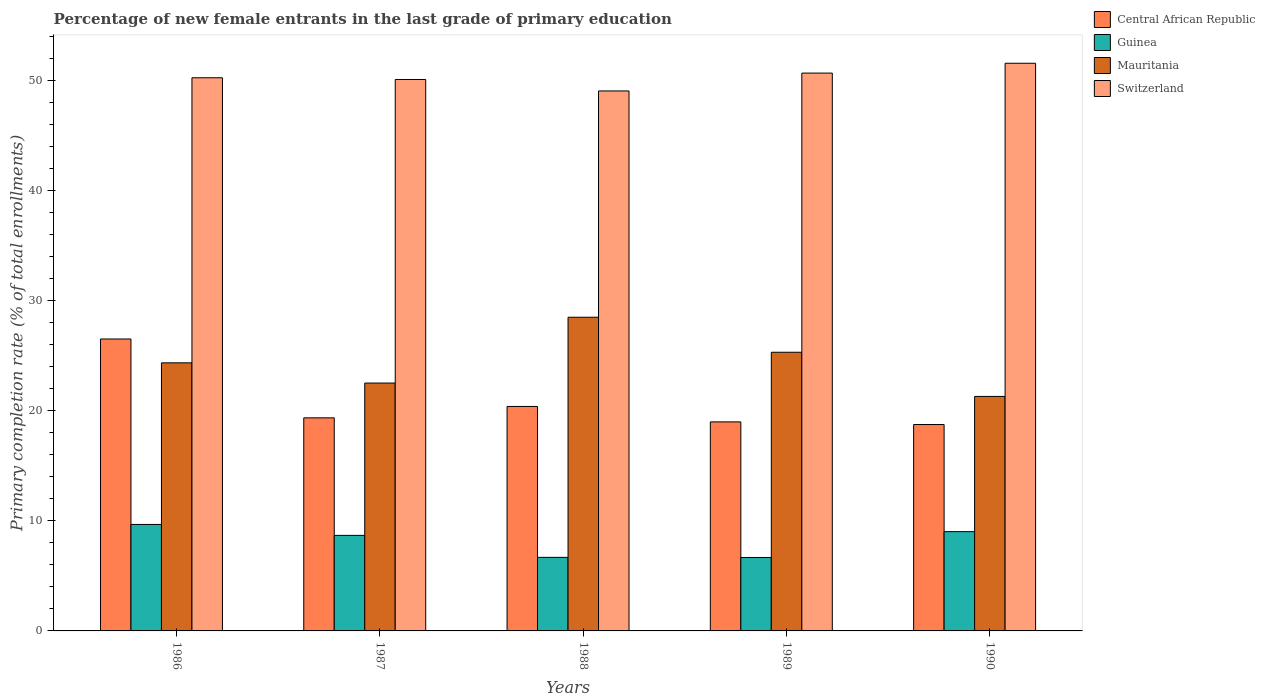Are the number of bars per tick equal to the number of legend labels?
Provide a succinct answer. Yes. How many bars are there on the 5th tick from the left?
Make the answer very short. 4. How many bars are there on the 3rd tick from the right?
Ensure brevity in your answer.  4. What is the percentage of new female entrants in Guinea in 1986?
Give a very brief answer. 9.67. Across all years, what is the maximum percentage of new female entrants in Guinea?
Your answer should be compact. 9.67. Across all years, what is the minimum percentage of new female entrants in Mauritania?
Provide a short and direct response. 21.31. In which year was the percentage of new female entrants in Guinea maximum?
Make the answer very short. 1986. In which year was the percentage of new female entrants in Mauritania minimum?
Keep it short and to the point. 1990. What is the total percentage of new female entrants in Guinea in the graph?
Give a very brief answer. 40.73. What is the difference between the percentage of new female entrants in Switzerland in 1986 and that in 1988?
Provide a short and direct response. 1.2. What is the difference between the percentage of new female entrants in Switzerland in 1987 and the percentage of new female entrants in Central African Republic in 1989?
Your response must be concise. 31.11. What is the average percentage of new female entrants in Mauritania per year?
Give a very brief answer. 24.4. In the year 1988, what is the difference between the percentage of new female entrants in Central African Republic and percentage of new female entrants in Guinea?
Your answer should be very brief. 13.71. What is the ratio of the percentage of new female entrants in Central African Republic in 1987 to that in 1990?
Your answer should be compact. 1.03. Is the percentage of new female entrants in Switzerland in 1987 less than that in 1989?
Provide a short and direct response. Yes. Is the difference between the percentage of new female entrants in Central African Republic in 1986 and 1989 greater than the difference between the percentage of new female entrants in Guinea in 1986 and 1989?
Offer a terse response. Yes. What is the difference between the highest and the second highest percentage of new female entrants in Switzerland?
Offer a terse response. 0.89. What is the difference between the highest and the lowest percentage of new female entrants in Mauritania?
Ensure brevity in your answer.  7.2. Is the sum of the percentage of new female entrants in Mauritania in 1986 and 1988 greater than the maximum percentage of new female entrants in Switzerland across all years?
Offer a terse response. Yes. What does the 3rd bar from the left in 1988 represents?
Ensure brevity in your answer.  Mauritania. What does the 3rd bar from the right in 1987 represents?
Offer a terse response. Guinea. How many bars are there?
Your response must be concise. 20. Are all the bars in the graph horizontal?
Provide a succinct answer. No. What is the difference between two consecutive major ticks on the Y-axis?
Provide a short and direct response. 10. Are the values on the major ticks of Y-axis written in scientific E-notation?
Provide a short and direct response. No. Does the graph contain any zero values?
Your answer should be compact. No. Does the graph contain grids?
Offer a terse response. No. How many legend labels are there?
Ensure brevity in your answer.  4. What is the title of the graph?
Provide a short and direct response. Percentage of new female entrants in the last grade of primary education. Does "Myanmar" appear as one of the legend labels in the graph?
Ensure brevity in your answer.  No. What is the label or title of the Y-axis?
Offer a very short reply. Primary completion rate (% of total enrollments). What is the Primary completion rate (% of total enrollments) of Central African Republic in 1986?
Give a very brief answer. 26.53. What is the Primary completion rate (% of total enrollments) of Guinea in 1986?
Make the answer very short. 9.67. What is the Primary completion rate (% of total enrollments) in Mauritania in 1986?
Keep it short and to the point. 24.36. What is the Primary completion rate (% of total enrollments) in Switzerland in 1986?
Give a very brief answer. 50.26. What is the Primary completion rate (% of total enrollments) in Central African Republic in 1987?
Provide a short and direct response. 19.36. What is the Primary completion rate (% of total enrollments) of Guinea in 1987?
Offer a very short reply. 8.68. What is the Primary completion rate (% of total enrollments) of Mauritania in 1987?
Give a very brief answer. 22.52. What is the Primary completion rate (% of total enrollments) in Switzerland in 1987?
Your answer should be compact. 50.11. What is the Primary completion rate (% of total enrollments) in Central African Republic in 1988?
Offer a terse response. 20.4. What is the Primary completion rate (% of total enrollments) in Guinea in 1988?
Offer a very short reply. 6.68. What is the Primary completion rate (% of total enrollments) in Mauritania in 1988?
Ensure brevity in your answer.  28.5. What is the Primary completion rate (% of total enrollments) in Switzerland in 1988?
Your response must be concise. 49.06. What is the Primary completion rate (% of total enrollments) in Central African Republic in 1989?
Provide a short and direct response. 18.99. What is the Primary completion rate (% of total enrollments) of Guinea in 1989?
Give a very brief answer. 6.67. What is the Primary completion rate (% of total enrollments) of Mauritania in 1989?
Your answer should be compact. 25.32. What is the Primary completion rate (% of total enrollments) in Switzerland in 1989?
Your answer should be very brief. 50.69. What is the Primary completion rate (% of total enrollments) in Central African Republic in 1990?
Give a very brief answer. 18.75. What is the Primary completion rate (% of total enrollments) in Guinea in 1990?
Your answer should be compact. 9.02. What is the Primary completion rate (% of total enrollments) of Mauritania in 1990?
Ensure brevity in your answer.  21.31. What is the Primary completion rate (% of total enrollments) of Switzerland in 1990?
Provide a succinct answer. 51.58. Across all years, what is the maximum Primary completion rate (% of total enrollments) of Central African Republic?
Your answer should be compact. 26.53. Across all years, what is the maximum Primary completion rate (% of total enrollments) of Guinea?
Give a very brief answer. 9.67. Across all years, what is the maximum Primary completion rate (% of total enrollments) in Mauritania?
Provide a succinct answer. 28.5. Across all years, what is the maximum Primary completion rate (% of total enrollments) of Switzerland?
Your response must be concise. 51.58. Across all years, what is the minimum Primary completion rate (% of total enrollments) of Central African Republic?
Offer a terse response. 18.75. Across all years, what is the minimum Primary completion rate (% of total enrollments) of Guinea?
Your answer should be compact. 6.67. Across all years, what is the minimum Primary completion rate (% of total enrollments) in Mauritania?
Provide a short and direct response. 21.31. Across all years, what is the minimum Primary completion rate (% of total enrollments) of Switzerland?
Ensure brevity in your answer.  49.06. What is the total Primary completion rate (% of total enrollments) in Central African Republic in the graph?
Your response must be concise. 104.03. What is the total Primary completion rate (% of total enrollments) in Guinea in the graph?
Give a very brief answer. 40.73. What is the total Primary completion rate (% of total enrollments) in Mauritania in the graph?
Your answer should be very brief. 122.01. What is the total Primary completion rate (% of total enrollments) of Switzerland in the graph?
Provide a short and direct response. 251.7. What is the difference between the Primary completion rate (% of total enrollments) of Central African Republic in 1986 and that in 1987?
Provide a short and direct response. 7.16. What is the difference between the Primary completion rate (% of total enrollments) in Guinea in 1986 and that in 1987?
Offer a very short reply. 0.99. What is the difference between the Primary completion rate (% of total enrollments) in Mauritania in 1986 and that in 1987?
Make the answer very short. 1.84. What is the difference between the Primary completion rate (% of total enrollments) of Switzerland in 1986 and that in 1987?
Keep it short and to the point. 0.16. What is the difference between the Primary completion rate (% of total enrollments) of Central African Republic in 1986 and that in 1988?
Offer a terse response. 6.13. What is the difference between the Primary completion rate (% of total enrollments) in Guinea in 1986 and that in 1988?
Offer a terse response. 2.99. What is the difference between the Primary completion rate (% of total enrollments) of Mauritania in 1986 and that in 1988?
Provide a succinct answer. -4.14. What is the difference between the Primary completion rate (% of total enrollments) of Switzerland in 1986 and that in 1988?
Your answer should be very brief. 1.2. What is the difference between the Primary completion rate (% of total enrollments) of Central African Republic in 1986 and that in 1989?
Your answer should be very brief. 7.53. What is the difference between the Primary completion rate (% of total enrollments) in Guinea in 1986 and that in 1989?
Provide a succinct answer. 3. What is the difference between the Primary completion rate (% of total enrollments) of Mauritania in 1986 and that in 1989?
Ensure brevity in your answer.  -0.96. What is the difference between the Primary completion rate (% of total enrollments) in Switzerland in 1986 and that in 1989?
Provide a succinct answer. -0.43. What is the difference between the Primary completion rate (% of total enrollments) of Central African Republic in 1986 and that in 1990?
Give a very brief answer. 7.77. What is the difference between the Primary completion rate (% of total enrollments) of Guinea in 1986 and that in 1990?
Give a very brief answer. 0.65. What is the difference between the Primary completion rate (% of total enrollments) of Mauritania in 1986 and that in 1990?
Your answer should be compact. 3.05. What is the difference between the Primary completion rate (% of total enrollments) of Switzerland in 1986 and that in 1990?
Your answer should be very brief. -1.32. What is the difference between the Primary completion rate (% of total enrollments) in Central African Republic in 1987 and that in 1988?
Make the answer very short. -1.03. What is the difference between the Primary completion rate (% of total enrollments) in Guinea in 1987 and that in 1988?
Offer a very short reply. 2. What is the difference between the Primary completion rate (% of total enrollments) of Mauritania in 1987 and that in 1988?
Provide a short and direct response. -5.98. What is the difference between the Primary completion rate (% of total enrollments) of Switzerland in 1987 and that in 1988?
Give a very brief answer. 1.04. What is the difference between the Primary completion rate (% of total enrollments) in Central African Republic in 1987 and that in 1989?
Your answer should be very brief. 0.37. What is the difference between the Primary completion rate (% of total enrollments) in Guinea in 1987 and that in 1989?
Provide a short and direct response. 2.01. What is the difference between the Primary completion rate (% of total enrollments) in Mauritania in 1987 and that in 1989?
Give a very brief answer. -2.8. What is the difference between the Primary completion rate (% of total enrollments) of Switzerland in 1987 and that in 1989?
Offer a terse response. -0.58. What is the difference between the Primary completion rate (% of total enrollments) in Central African Republic in 1987 and that in 1990?
Give a very brief answer. 0.61. What is the difference between the Primary completion rate (% of total enrollments) of Guinea in 1987 and that in 1990?
Your answer should be very brief. -0.34. What is the difference between the Primary completion rate (% of total enrollments) in Mauritania in 1987 and that in 1990?
Keep it short and to the point. 1.22. What is the difference between the Primary completion rate (% of total enrollments) of Switzerland in 1987 and that in 1990?
Make the answer very short. -1.47. What is the difference between the Primary completion rate (% of total enrollments) in Central African Republic in 1988 and that in 1989?
Ensure brevity in your answer.  1.4. What is the difference between the Primary completion rate (% of total enrollments) in Guinea in 1988 and that in 1989?
Make the answer very short. 0.01. What is the difference between the Primary completion rate (% of total enrollments) in Mauritania in 1988 and that in 1989?
Give a very brief answer. 3.18. What is the difference between the Primary completion rate (% of total enrollments) of Switzerland in 1988 and that in 1989?
Your answer should be very brief. -1.62. What is the difference between the Primary completion rate (% of total enrollments) in Central African Republic in 1988 and that in 1990?
Ensure brevity in your answer.  1.64. What is the difference between the Primary completion rate (% of total enrollments) in Guinea in 1988 and that in 1990?
Your response must be concise. -2.34. What is the difference between the Primary completion rate (% of total enrollments) of Mauritania in 1988 and that in 1990?
Your answer should be compact. 7.2. What is the difference between the Primary completion rate (% of total enrollments) in Switzerland in 1988 and that in 1990?
Your answer should be compact. -2.52. What is the difference between the Primary completion rate (% of total enrollments) of Central African Republic in 1989 and that in 1990?
Offer a terse response. 0.24. What is the difference between the Primary completion rate (% of total enrollments) of Guinea in 1989 and that in 1990?
Keep it short and to the point. -2.35. What is the difference between the Primary completion rate (% of total enrollments) of Mauritania in 1989 and that in 1990?
Your answer should be very brief. 4.01. What is the difference between the Primary completion rate (% of total enrollments) in Switzerland in 1989 and that in 1990?
Your response must be concise. -0.89. What is the difference between the Primary completion rate (% of total enrollments) of Central African Republic in 1986 and the Primary completion rate (% of total enrollments) of Guinea in 1987?
Offer a terse response. 17.84. What is the difference between the Primary completion rate (% of total enrollments) of Central African Republic in 1986 and the Primary completion rate (% of total enrollments) of Mauritania in 1987?
Offer a very short reply. 4. What is the difference between the Primary completion rate (% of total enrollments) in Central African Republic in 1986 and the Primary completion rate (% of total enrollments) in Switzerland in 1987?
Offer a terse response. -23.58. What is the difference between the Primary completion rate (% of total enrollments) in Guinea in 1986 and the Primary completion rate (% of total enrollments) in Mauritania in 1987?
Your answer should be compact. -12.85. What is the difference between the Primary completion rate (% of total enrollments) of Guinea in 1986 and the Primary completion rate (% of total enrollments) of Switzerland in 1987?
Your answer should be very brief. -40.43. What is the difference between the Primary completion rate (% of total enrollments) of Mauritania in 1986 and the Primary completion rate (% of total enrollments) of Switzerland in 1987?
Make the answer very short. -25.75. What is the difference between the Primary completion rate (% of total enrollments) in Central African Republic in 1986 and the Primary completion rate (% of total enrollments) in Guinea in 1988?
Make the answer very short. 19.84. What is the difference between the Primary completion rate (% of total enrollments) of Central African Republic in 1986 and the Primary completion rate (% of total enrollments) of Mauritania in 1988?
Provide a short and direct response. -1.98. What is the difference between the Primary completion rate (% of total enrollments) in Central African Republic in 1986 and the Primary completion rate (% of total enrollments) in Switzerland in 1988?
Give a very brief answer. -22.54. What is the difference between the Primary completion rate (% of total enrollments) in Guinea in 1986 and the Primary completion rate (% of total enrollments) in Mauritania in 1988?
Your answer should be compact. -18.83. What is the difference between the Primary completion rate (% of total enrollments) of Guinea in 1986 and the Primary completion rate (% of total enrollments) of Switzerland in 1988?
Ensure brevity in your answer.  -39.39. What is the difference between the Primary completion rate (% of total enrollments) in Mauritania in 1986 and the Primary completion rate (% of total enrollments) in Switzerland in 1988?
Ensure brevity in your answer.  -24.71. What is the difference between the Primary completion rate (% of total enrollments) in Central African Republic in 1986 and the Primary completion rate (% of total enrollments) in Guinea in 1989?
Keep it short and to the point. 19.85. What is the difference between the Primary completion rate (% of total enrollments) in Central African Republic in 1986 and the Primary completion rate (% of total enrollments) in Mauritania in 1989?
Your answer should be very brief. 1.21. What is the difference between the Primary completion rate (% of total enrollments) in Central African Republic in 1986 and the Primary completion rate (% of total enrollments) in Switzerland in 1989?
Offer a terse response. -24.16. What is the difference between the Primary completion rate (% of total enrollments) of Guinea in 1986 and the Primary completion rate (% of total enrollments) of Mauritania in 1989?
Offer a very short reply. -15.65. What is the difference between the Primary completion rate (% of total enrollments) of Guinea in 1986 and the Primary completion rate (% of total enrollments) of Switzerland in 1989?
Make the answer very short. -41.01. What is the difference between the Primary completion rate (% of total enrollments) in Mauritania in 1986 and the Primary completion rate (% of total enrollments) in Switzerland in 1989?
Make the answer very short. -26.33. What is the difference between the Primary completion rate (% of total enrollments) of Central African Republic in 1986 and the Primary completion rate (% of total enrollments) of Guinea in 1990?
Give a very brief answer. 17.5. What is the difference between the Primary completion rate (% of total enrollments) of Central African Republic in 1986 and the Primary completion rate (% of total enrollments) of Mauritania in 1990?
Your answer should be very brief. 5.22. What is the difference between the Primary completion rate (% of total enrollments) of Central African Republic in 1986 and the Primary completion rate (% of total enrollments) of Switzerland in 1990?
Give a very brief answer. -25.05. What is the difference between the Primary completion rate (% of total enrollments) in Guinea in 1986 and the Primary completion rate (% of total enrollments) in Mauritania in 1990?
Ensure brevity in your answer.  -11.63. What is the difference between the Primary completion rate (% of total enrollments) of Guinea in 1986 and the Primary completion rate (% of total enrollments) of Switzerland in 1990?
Offer a very short reply. -41.91. What is the difference between the Primary completion rate (% of total enrollments) in Mauritania in 1986 and the Primary completion rate (% of total enrollments) in Switzerland in 1990?
Give a very brief answer. -27.22. What is the difference between the Primary completion rate (% of total enrollments) in Central African Republic in 1987 and the Primary completion rate (% of total enrollments) in Guinea in 1988?
Give a very brief answer. 12.68. What is the difference between the Primary completion rate (% of total enrollments) in Central African Republic in 1987 and the Primary completion rate (% of total enrollments) in Mauritania in 1988?
Provide a short and direct response. -9.14. What is the difference between the Primary completion rate (% of total enrollments) of Central African Republic in 1987 and the Primary completion rate (% of total enrollments) of Switzerland in 1988?
Provide a succinct answer. -29.7. What is the difference between the Primary completion rate (% of total enrollments) of Guinea in 1987 and the Primary completion rate (% of total enrollments) of Mauritania in 1988?
Your answer should be very brief. -19.82. What is the difference between the Primary completion rate (% of total enrollments) of Guinea in 1987 and the Primary completion rate (% of total enrollments) of Switzerland in 1988?
Ensure brevity in your answer.  -40.38. What is the difference between the Primary completion rate (% of total enrollments) of Mauritania in 1987 and the Primary completion rate (% of total enrollments) of Switzerland in 1988?
Provide a succinct answer. -26.54. What is the difference between the Primary completion rate (% of total enrollments) in Central African Republic in 1987 and the Primary completion rate (% of total enrollments) in Guinea in 1989?
Ensure brevity in your answer.  12.69. What is the difference between the Primary completion rate (% of total enrollments) of Central African Republic in 1987 and the Primary completion rate (% of total enrollments) of Mauritania in 1989?
Offer a terse response. -5.96. What is the difference between the Primary completion rate (% of total enrollments) of Central African Republic in 1987 and the Primary completion rate (% of total enrollments) of Switzerland in 1989?
Make the answer very short. -31.33. What is the difference between the Primary completion rate (% of total enrollments) of Guinea in 1987 and the Primary completion rate (% of total enrollments) of Mauritania in 1989?
Your answer should be very brief. -16.64. What is the difference between the Primary completion rate (% of total enrollments) in Guinea in 1987 and the Primary completion rate (% of total enrollments) in Switzerland in 1989?
Make the answer very short. -42.01. What is the difference between the Primary completion rate (% of total enrollments) of Mauritania in 1987 and the Primary completion rate (% of total enrollments) of Switzerland in 1989?
Offer a very short reply. -28.17. What is the difference between the Primary completion rate (% of total enrollments) of Central African Republic in 1987 and the Primary completion rate (% of total enrollments) of Guinea in 1990?
Make the answer very short. 10.34. What is the difference between the Primary completion rate (% of total enrollments) in Central African Republic in 1987 and the Primary completion rate (% of total enrollments) in Mauritania in 1990?
Give a very brief answer. -1.95. What is the difference between the Primary completion rate (% of total enrollments) of Central African Republic in 1987 and the Primary completion rate (% of total enrollments) of Switzerland in 1990?
Your answer should be compact. -32.22. What is the difference between the Primary completion rate (% of total enrollments) in Guinea in 1987 and the Primary completion rate (% of total enrollments) in Mauritania in 1990?
Make the answer very short. -12.62. What is the difference between the Primary completion rate (% of total enrollments) of Guinea in 1987 and the Primary completion rate (% of total enrollments) of Switzerland in 1990?
Provide a short and direct response. -42.9. What is the difference between the Primary completion rate (% of total enrollments) of Mauritania in 1987 and the Primary completion rate (% of total enrollments) of Switzerland in 1990?
Ensure brevity in your answer.  -29.06. What is the difference between the Primary completion rate (% of total enrollments) of Central African Republic in 1988 and the Primary completion rate (% of total enrollments) of Guinea in 1989?
Offer a terse response. 13.72. What is the difference between the Primary completion rate (% of total enrollments) of Central African Republic in 1988 and the Primary completion rate (% of total enrollments) of Mauritania in 1989?
Provide a short and direct response. -4.92. What is the difference between the Primary completion rate (% of total enrollments) in Central African Republic in 1988 and the Primary completion rate (% of total enrollments) in Switzerland in 1989?
Your answer should be very brief. -30.29. What is the difference between the Primary completion rate (% of total enrollments) of Guinea in 1988 and the Primary completion rate (% of total enrollments) of Mauritania in 1989?
Give a very brief answer. -18.64. What is the difference between the Primary completion rate (% of total enrollments) of Guinea in 1988 and the Primary completion rate (% of total enrollments) of Switzerland in 1989?
Your response must be concise. -44. What is the difference between the Primary completion rate (% of total enrollments) of Mauritania in 1988 and the Primary completion rate (% of total enrollments) of Switzerland in 1989?
Provide a succinct answer. -22.19. What is the difference between the Primary completion rate (% of total enrollments) of Central African Republic in 1988 and the Primary completion rate (% of total enrollments) of Guinea in 1990?
Your answer should be very brief. 11.37. What is the difference between the Primary completion rate (% of total enrollments) in Central African Republic in 1988 and the Primary completion rate (% of total enrollments) in Mauritania in 1990?
Make the answer very short. -0.91. What is the difference between the Primary completion rate (% of total enrollments) in Central African Republic in 1988 and the Primary completion rate (% of total enrollments) in Switzerland in 1990?
Offer a terse response. -31.18. What is the difference between the Primary completion rate (% of total enrollments) in Guinea in 1988 and the Primary completion rate (% of total enrollments) in Mauritania in 1990?
Offer a terse response. -14.62. What is the difference between the Primary completion rate (% of total enrollments) in Guinea in 1988 and the Primary completion rate (% of total enrollments) in Switzerland in 1990?
Keep it short and to the point. -44.9. What is the difference between the Primary completion rate (% of total enrollments) in Mauritania in 1988 and the Primary completion rate (% of total enrollments) in Switzerland in 1990?
Offer a very short reply. -23.08. What is the difference between the Primary completion rate (% of total enrollments) in Central African Republic in 1989 and the Primary completion rate (% of total enrollments) in Guinea in 1990?
Keep it short and to the point. 9.97. What is the difference between the Primary completion rate (% of total enrollments) in Central African Republic in 1989 and the Primary completion rate (% of total enrollments) in Mauritania in 1990?
Offer a very short reply. -2.31. What is the difference between the Primary completion rate (% of total enrollments) in Central African Republic in 1989 and the Primary completion rate (% of total enrollments) in Switzerland in 1990?
Offer a terse response. -32.59. What is the difference between the Primary completion rate (% of total enrollments) in Guinea in 1989 and the Primary completion rate (% of total enrollments) in Mauritania in 1990?
Give a very brief answer. -14.63. What is the difference between the Primary completion rate (% of total enrollments) of Guinea in 1989 and the Primary completion rate (% of total enrollments) of Switzerland in 1990?
Offer a terse response. -44.91. What is the difference between the Primary completion rate (% of total enrollments) in Mauritania in 1989 and the Primary completion rate (% of total enrollments) in Switzerland in 1990?
Offer a very short reply. -26.26. What is the average Primary completion rate (% of total enrollments) of Central African Republic per year?
Keep it short and to the point. 20.81. What is the average Primary completion rate (% of total enrollments) in Guinea per year?
Provide a short and direct response. 8.15. What is the average Primary completion rate (% of total enrollments) of Mauritania per year?
Your answer should be compact. 24.4. What is the average Primary completion rate (% of total enrollments) of Switzerland per year?
Your answer should be compact. 50.34. In the year 1986, what is the difference between the Primary completion rate (% of total enrollments) of Central African Republic and Primary completion rate (% of total enrollments) of Guinea?
Provide a short and direct response. 16.85. In the year 1986, what is the difference between the Primary completion rate (% of total enrollments) in Central African Republic and Primary completion rate (% of total enrollments) in Mauritania?
Ensure brevity in your answer.  2.17. In the year 1986, what is the difference between the Primary completion rate (% of total enrollments) in Central African Republic and Primary completion rate (% of total enrollments) in Switzerland?
Make the answer very short. -23.74. In the year 1986, what is the difference between the Primary completion rate (% of total enrollments) in Guinea and Primary completion rate (% of total enrollments) in Mauritania?
Your response must be concise. -14.68. In the year 1986, what is the difference between the Primary completion rate (% of total enrollments) in Guinea and Primary completion rate (% of total enrollments) in Switzerland?
Give a very brief answer. -40.59. In the year 1986, what is the difference between the Primary completion rate (% of total enrollments) of Mauritania and Primary completion rate (% of total enrollments) of Switzerland?
Ensure brevity in your answer.  -25.9. In the year 1987, what is the difference between the Primary completion rate (% of total enrollments) in Central African Republic and Primary completion rate (% of total enrollments) in Guinea?
Give a very brief answer. 10.68. In the year 1987, what is the difference between the Primary completion rate (% of total enrollments) in Central African Republic and Primary completion rate (% of total enrollments) in Mauritania?
Offer a terse response. -3.16. In the year 1987, what is the difference between the Primary completion rate (% of total enrollments) in Central African Republic and Primary completion rate (% of total enrollments) in Switzerland?
Your response must be concise. -30.74. In the year 1987, what is the difference between the Primary completion rate (% of total enrollments) of Guinea and Primary completion rate (% of total enrollments) of Mauritania?
Offer a very short reply. -13.84. In the year 1987, what is the difference between the Primary completion rate (% of total enrollments) in Guinea and Primary completion rate (% of total enrollments) in Switzerland?
Your answer should be very brief. -41.42. In the year 1987, what is the difference between the Primary completion rate (% of total enrollments) in Mauritania and Primary completion rate (% of total enrollments) in Switzerland?
Keep it short and to the point. -27.58. In the year 1988, what is the difference between the Primary completion rate (% of total enrollments) in Central African Republic and Primary completion rate (% of total enrollments) in Guinea?
Your response must be concise. 13.71. In the year 1988, what is the difference between the Primary completion rate (% of total enrollments) of Central African Republic and Primary completion rate (% of total enrollments) of Mauritania?
Your response must be concise. -8.11. In the year 1988, what is the difference between the Primary completion rate (% of total enrollments) of Central African Republic and Primary completion rate (% of total enrollments) of Switzerland?
Your answer should be very brief. -28.67. In the year 1988, what is the difference between the Primary completion rate (% of total enrollments) in Guinea and Primary completion rate (% of total enrollments) in Mauritania?
Provide a short and direct response. -21.82. In the year 1988, what is the difference between the Primary completion rate (% of total enrollments) of Guinea and Primary completion rate (% of total enrollments) of Switzerland?
Your answer should be compact. -42.38. In the year 1988, what is the difference between the Primary completion rate (% of total enrollments) in Mauritania and Primary completion rate (% of total enrollments) in Switzerland?
Make the answer very short. -20.56. In the year 1989, what is the difference between the Primary completion rate (% of total enrollments) of Central African Republic and Primary completion rate (% of total enrollments) of Guinea?
Offer a terse response. 12.32. In the year 1989, what is the difference between the Primary completion rate (% of total enrollments) of Central African Republic and Primary completion rate (% of total enrollments) of Mauritania?
Offer a very short reply. -6.33. In the year 1989, what is the difference between the Primary completion rate (% of total enrollments) of Central African Republic and Primary completion rate (% of total enrollments) of Switzerland?
Provide a short and direct response. -31.69. In the year 1989, what is the difference between the Primary completion rate (% of total enrollments) of Guinea and Primary completion rate (% of total enrollments) of Mauritania?
Offer a terse response. -18.65. In the year 1989, what is the difference between the Primary completion rate (% of total enrollments) in Guinea and Primary completion rate (% of total enrollments) in Switzerland?
Provide a succinct answer. -44.02. In the year 1989, what is the difference between the Primary completion rate (% of total enrollments) of Mauritania and Primary completion rate (% of total enrollments) of Switzerland?
Provide a succinct answer. -25.37. In the year 1990, what is the difference between the Primary completion rate (% of total enrollments) in Central African Republic and Primary completion rate (% of total enrollments) in Guinea?
Give a very brief answer. 9.73. In the year 1990, what is the difference between the Primary completion rate (% of total enrollments) of Central African Republic and Primary completion rate (% of total enrollments) of Mauritania?
Your answer should be very brief. -2.55. In the year 1990, what is the difference between the Primary completion rate (% of total enrollments) in Central African Republic and Primary completion rate (% of total enrollments) in Switzerland?
Give a very brief answer. -32.83. In the year 1990, what is the difference between the Primary completion rate (% of total enrollments) in Guinea and Primary completion rate (% of total enrollments) in Mauritania?
Provide a short and direct response. -12.29. In the year 1990, what is the difference between the Primary completion rate (% of total enrollments) in Guinea and Primary completion rate (% of total enrollments) in Switzerland?
Your answer should be very brief. -42.56. In the year 1990, what is the difference between the Primary completion rate (% of total enrollments) of Mauritania and Primary completion rate (% of total enrollments) of Switzerland?
Make the answer very short. -30.27. What is the ratio of the Primary completion rate (% of total enrollments) in Central African Republic in 1986 to that in 1987?
Provide a succinct answer. 1.37. What is the ratio of the Primary completion rate (% of total enrollments) in Guinea in 1986 to that in 1987?
Your response must be concise. 1.11. What is the ratio of the Primary completion rate (% of total enrollments) of Mauritania in 1986 to that in 1987?
Provide a succinct answer. 1.08. What is the ratio of the Primary completion rate (% of total enrollments) in Central African Republic in 1986 to that in 1988?
Provide a succinct answer. 1.3. What is the ratio of the Primary completion rate (% of total enrollments) in Guinea in 1986 to that in 1988?
Provide a succinct answer. 1.45. What is the ratio of the Primary completion rate (% of total enrollments) of Mauritania in 1986 to that in 1988?
Keep it short and to the point. 0.85. What is the ratio of the Primary completion rate (% of total enrollments) of Switzerland in 1986 to that in 1988?
Your answer should be very brief. 1.02. What is the ratio of the Primary completion rate (% of total enrollments) in Central African Republic in 1986 to that in 1989?
Provide a short and direct response. 1.4. What is the ratio of the Primary completion rate (% of total enrollments) of Guinea in 1986 to that in 1989?
Ensure brevity in your answer.  1.45. What is the ratio of the Primary completion rate (% of total enrollments) of Central African Republic in 1986 to that in 1990?
Give a very brief answer. 1.41. What is the ratio of the Primary completion rate (% of total enrollments) in Guinea in 1986 to that in 1990?
Give a very brief answer. 1.07. What is the ratio of the Primary completion rate (% of total enrollments) in Mauritania in 1986 to that in 1990?
Give a very brief answer. 1.14. What is the ratio of the Primary completion rate (% of total enrollments) in Switzerland in 1986 to that in 1990?
Ensure brevity in your answer.  0.97. What is the ratio of the Primary completion rate (% of total enrollments) of Central African Republic in 1987 to that in 1988?
Your answer should be very brief. 0.95. What is the ratio of the Primary completion rate (% of total enrollments) in Guinea in 1987 to that in 1988?
Make the answer very short. 1.3. What is the ratio of the Primary completion rate (% of total enrollments) of Mauritania in 1987 to that in 1988?
Give a very brief answer. 0.79. What is the ratio of the Primary completion rate (% of total enrollments) of Switzerland in 1987 to that in 1988?
Keep it short and to the point. 1.02. What is the ratio of the Primary completion rate (% of total enrollments) of Central African Republic in 1987 to that in 1989?
Your answer should be compact. 1.02. What is the ratio of the Primary completion rate (% of total enrollments) in Guinea in 1987 to that in 1989?
Provide a succinct answer. 1.3. What is the ratio of the Primary completion rate (% of total enrollments) of Mauritania in 1987 to that in 1989?
Make the answer very short. 0.89. What is the ratio of the Primary completion rate (% of total enrollments) in Switzerland in 1987 to that in 1989?
Keep it short and to the point. 0.99. What is the ratio of the Primary completion rate (% of total enrollments) in Central African Republic in 1987 to that in 1990?
Offer a very short reply. 1.03. What is the ratio of the Primary completion rate (% of total enrollments) in Guinea in 1987 to that in 1990?
Keep it short and to the point. 0.96. What is the ratio of the Primary completion rate (% of total enrollments) of Mauritania in 1987 to that in 1990?
Your answer should be compact. 1.06. What is the ratio of the Primary completion rate (% of total enrollments) in Switzerland in 1987 to that in 1990?
Provide a short and direct response. 0.97. What is the ratio of the Primary completion rate (% of total enrollments) in Central African Republic in 1988 to that in 1989?
Your answer should be very brief. 1.07. What is the ratio of the Primary completion rate (% of total enrollments) in Mauritania in 1988 to that in 1989?
Provide a short and direct response. 1.13. What is the ratio of the Primary completion rate (% of total enrollments) of Switzerland in 1988 to that in 1989?
Make the answer very short. 0.97. What is the ratio of the Primary completion rate (% of total enrollments) of Central African Republic in 1988 to that in 1990?
Offer a very short reply. 1.09. What is the ratio of the Primary completion rate (% of total enrollments) in Guinea in 1988 to that in 1990?
Provide a succinct answer. 0.74. What is the ratio of the Primary completion rate (% of total enrollments) in Mauritania in 1988 to that in 1990?
Your answer should be compact. 1.34. What is the ratio of the Primary completion rate (% of total enrollments) in Switzerland in 1988 to that in 1990?
Offer a very short reply. 0.95. What is the ratio of the Primary completion rate (% of total enrollments) of Central African Republic in 1989 to that in 1990?
Your answer should be compact. 1.01. What is the ratio of the Primary completion rate (% of total enrollments) in Guinea in 1989 to that in 1990?
Your response must be concise. 0.74. What is the ratio of the Primary completion rate (% of total enrollments) in Mauritania in 1989 to that in 1990?
Your answer should be very brief. 1.19. What is the ratio of the Primary completion rate (% of total enrollments) in Switzerland in 1989 to that in 1990?
Your answer should be very brief. 0.98. What is the difference between the highest and the second highest Primary completion rate (% of total enrollments) in Central African Republic?
Your answer should be very brief. 6.13. What is the difference between the highest and the second highest Primary completion rate (% of total enrollments) in Guinea?
Offer a very short reply. 0.65. What is the difference between the highest and the second highest Primary completion rate (% of total enrollments) of Mauritania?
Offer a very short reply. 3.18. What is the difference between the highest and the second highest Primary completion rate (% of total enrollments) of Switzerland?
Provide a succinct answer. 0.89. What is the difference between the highest and the lowest Primary completion rate (% of total enrollments) in Central African Republic?
Your answer should be very brief. 7.77. What is the difference between the highest and the lowest Primary completion rate (% of total enrollments) of Guinea?
Keep it short and to the point. 3. What is the difference between the highest and the lowest Primary completion rate (% of total enrollments) in Mauritania?
Your answer should be compact. 7.2. What is the difference between the highest and the lowest Primary completion rate (% of total enrollments) of Switzerland?
Make the answer very short. 2.52. 